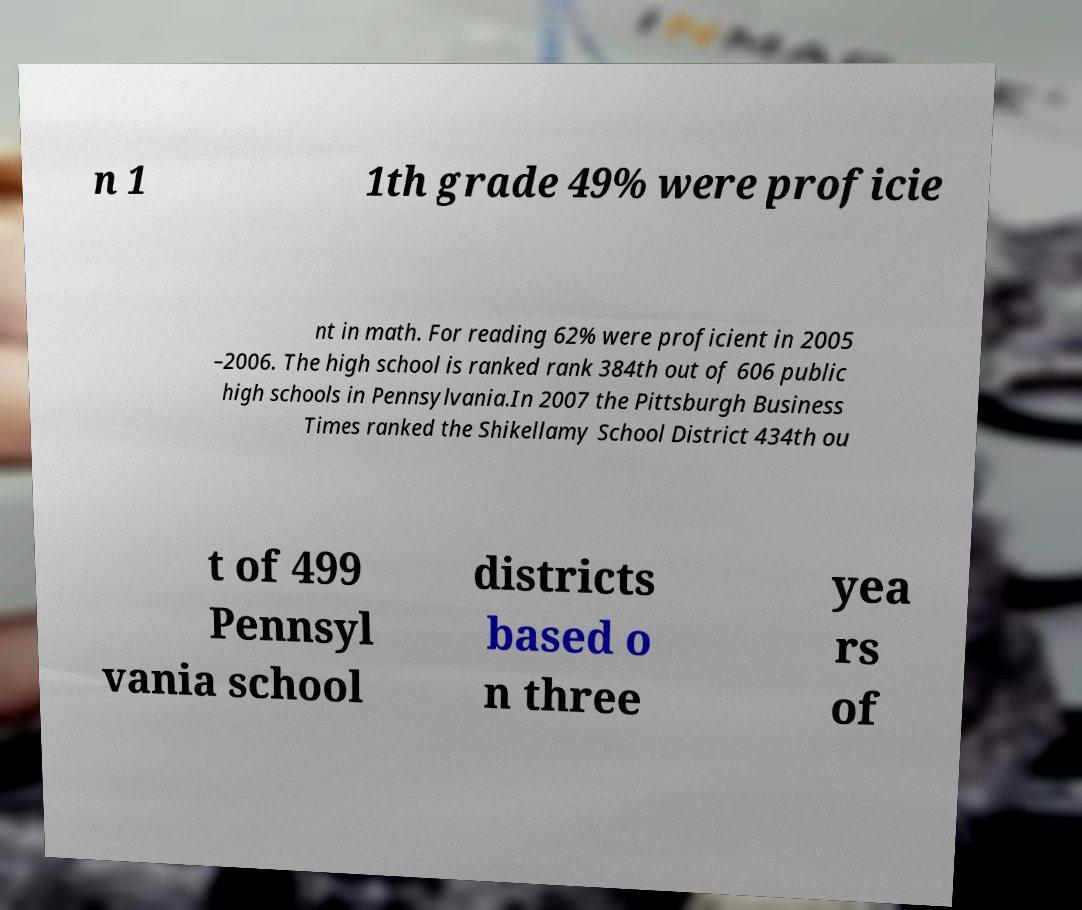Can you accurately transcribe the text from the provided image for me? n 1 1th grade 49% were proficie nt in math. For reading 62% were proficient in 2005 –2006. The high school is ranked rank 384th out of 606 public high schools in Pennsylvania.In 2007 the Pittsburgh Business Times ranked the Shikellamy School District 434th ou t of 499 Pennsyl vania school districts based o n three yea rs of 